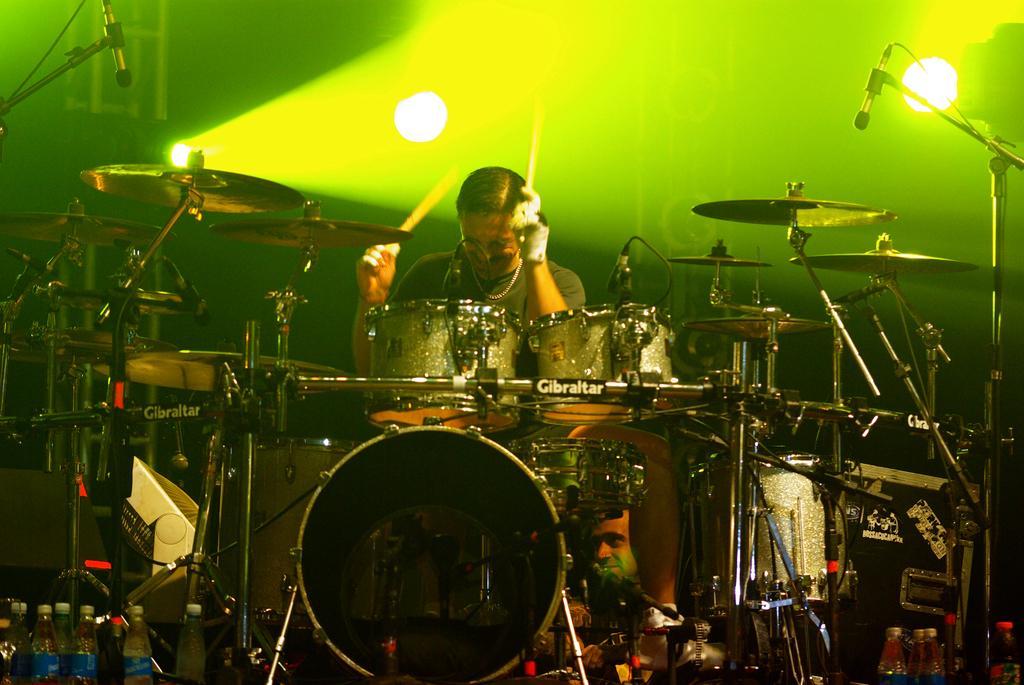Could you give a brief overview of what you see in this image? In this picture, there is a man playing musical instruments with sticks. On either side of the image, there are mike's. In the background, there is a green light. At the bottom, there are bottles. 